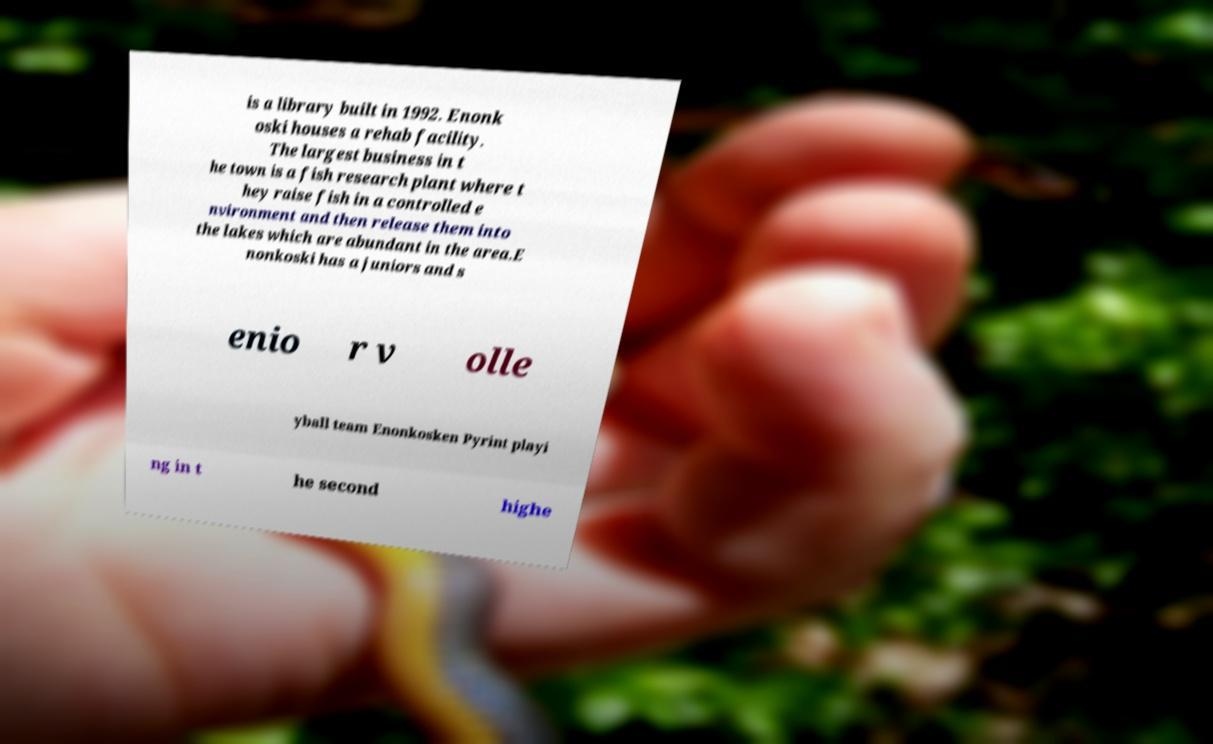Please read and relay the text visible in this image. What does it say? is a library built in 1992. Enonk oski houses a rehab facility. The largest business in t he town is a fish research plant where t hey raise fish in a controlled e nvironment and then release them into the lakes which are abundant in the area.E nonkoski has a juniors and s enio r v olle yball team Enonkosken Pyrint playi ng in t he second highe 